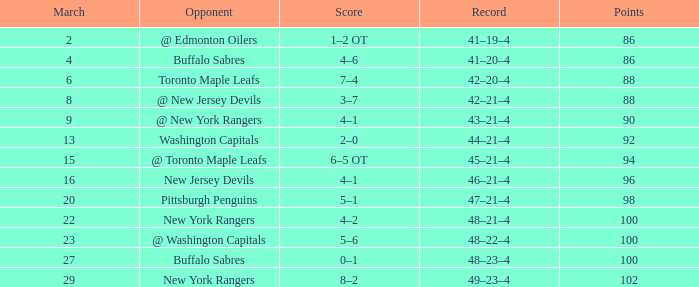Which Opponent has a Record of 45–21–4? @ Toronto Maple Leafs. 